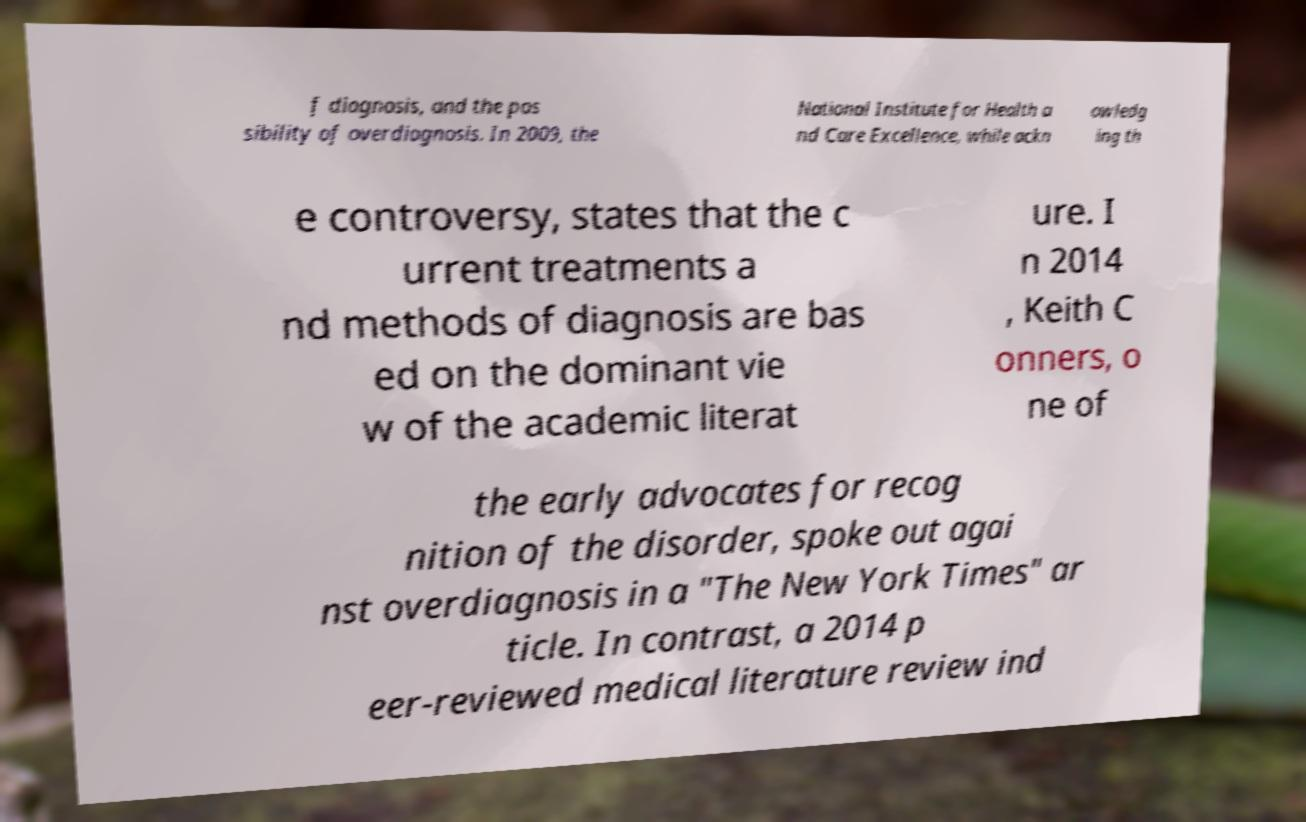I need the written content from this picture converted into text. Can you do that? f diagnosis, and the pos sibility of overdiagnosis. In 2009, the National Institute for Health a nd Care Excellence, while ackn owledg ing th e controversy, states that the c urrent treatments a nd methods of diagnosis are bas ed on the dominant vie w of the academic literat ure. I n 2014 , Keith C onners, o ne of the early advocates for recog nition of the disorder, spoke out agai nst overdiagnosis in a "The New York Times" ar ticle. In contrast, a 2014 p eer-reviewed medical literature review ind 